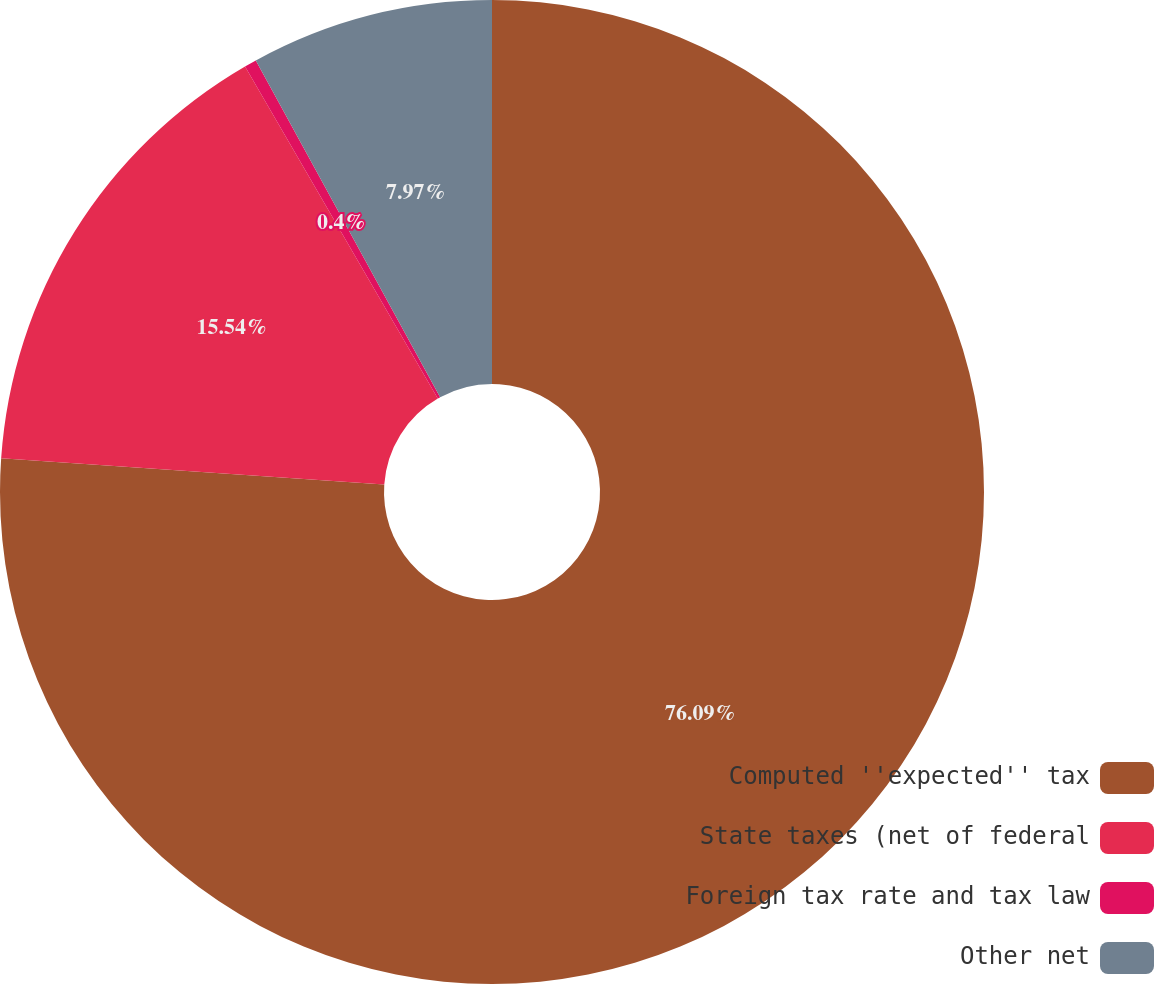<chart> <loc_0><loc_0><loc_500><loc_500><pie_chart><fcel>Computed ''expected'' tax<fcel>State taxes (net of federal<fcel>Foreign tax rate and tax law<fcel>Other net<nl><fcel>76.1%<fcel>15.54%<fcel>0.4%<fcel>7.97%<nl></chart> 